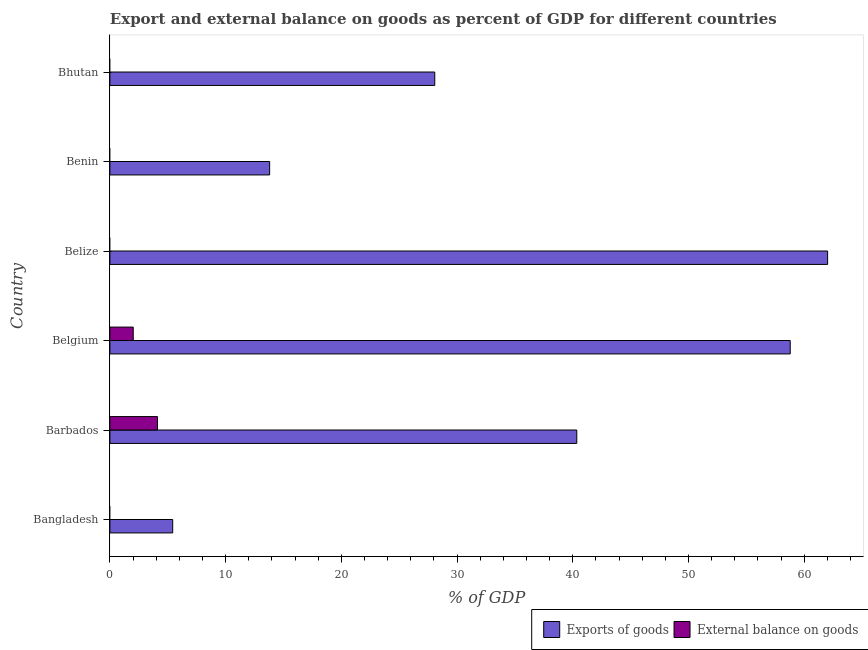Are the number of bars on each tick of the Y-axis equal?
Your response must be concise. No. How many bars are there on the 2nd tick from the bottom?
Ensure brevity in your answer.  2. What is the label of the 2nd group of bars from the top?
Keep it short and to the point. Benin. What is the export of goods as percentage of gdp in Benin?
Offer a very short reply. 13.8. Across all countries, what is the maximum external balance on goods as percentage of gdp?
Your answer should be very brief. 4.11. Across all countries, what is the minimum export of goods as percentage of gdp?
Your answer should be compact. 5.43. In which country was the export of goods as percentage of gdp maximum?
Provide a short and direct response. Belize. What is the total export of goods as percentage of gdp in the graph?
Provide a short and direct response. 208.46. What is the difference between the export of goods as percentage of gdp in Bangladesh and that in Bhutan?
Your answer should be compact. -22.64. What is the difference between the export of goods as percentage of gdp in Barbados and the external balance on goods as percentage of gdp in Belize?
Offer a terse response. 40.35. What is the average external balance on goods as percentage of gdp per country?
Offer a very short reply. 1.02. What is the difference between the external balance on goods as percentage of gdp and export of goods as percentage of gdp in Barbados?
Ensure brevity in your answer.  -36.23. In how many countries, is the external balance on goods as percentage of gdp greater than 18 %?
Provide a succinct answer. 0. What is the ratio of the export of goods as percentage of gdp in Bangladesh to that in Belgium?
Your response must be concise. 0.09. Is the difference between the export of goods as percentage of gdp in Barbados and Belgium greater than the difference between the external balance on goods as percentage of gdp in Barbados and Belgium?
Make the answer very short. No. What is the difference between the highest and the second highest export of goods as percentage of gdp?
Offer a terse response. 3.23. What is the difference between the highest and the lowest export of goods as percentage of gdp?
Offer a very short reply. 56.59. In how many countries, is the export of goods as percentage of gdp greater than the average export of goods as percentage of gdp taken over all countries?
Offer a very short reply. 3. Is the sum of the export of goods as percentage of gdp in Bangladesh and Bhutan greater than the maximum external balance on goods as percentage of gdp across all countries?
Ensure brevity in your answer.  Yes. Are all the bars in the graph horizontal?
Your answer should be very brief. Yes. How many countries are there in the graph?
Provide a succinct answer. 6. What is the difference between two consecutive major ticks on the X-axis?
Your answer should be compact. 10. Are the values on the major ticks of X-axis written in scientific E-notation?
Your answer should be compact. No. Does the graph contain any zero values?
Your answer should be very brief. Yes. Does the graph contain grids?
Your response must be concise. No. What is the title of the graph?
Offer a very short reply. Export and external balance on goods as percent of GDP for different countries. What is the label or title of the X-axis?
Ensure brevity in your answer.  % of GDP. What is the % of GDP of Exports of goods in Bangladesh?
Provide a succinct answer. 5.43. What is the % of GDP of External balance on goods in Bangladesh?
Keep it short and to the point. 0. What is the % of GDP in Exports of goods in Barbados?
Offer a very short reply. 40.35. What is the % of GDP in External balance on goods in Barbados?
Give a very brief answer. 4.11. What is the % of GDP in Exports of goods in Belgium?
Provide a short and direct response. 58.79. What is the % of GDP in External balance on goods in Belgium?
Your answer should be very brief. 2.02. What is the % of GDP of Exports of goods in Belize?
Your response must be concise. 62.02. What is the % of GDP in External balance on goods in Belize?
Give a very brief answer. 0. What is the % of GDP of Exports of goods in Benin?
Your response must be concise. 13.8. What is the % of GDP in Exports of goods in Bhutan?
Ensure brevity in your answer.  28.07. What is the % of GDP of External balance on goods in Bhutan?
Offer a very short reply. 0. Across all countries, what is the maximum % of GDP in Exports of goods?
Make the answer very short. 62.02. Across all countries, what is the maximum % of GDP of External balance on goods?
Provide a short and direct response. 4.11. Across all countries, what is the minimum % of GDP in Exports of goods?
Offer a very short reply. 5.43. Across all countries, what is the minimum % of GDP of External balance on goods?
Give a very brief answer. 0. What is the total % of GDP in Exports of goods in the graph?
Your response must be concise. 208.46. What is the total % of GDP in External balance on goods in the graph?
Your response must be concise. 6.13. What is the difference between the % of GDP in Exports of goods in Bangladesh and that in Barbados?
Give a very brief answer. -34.92. What is the difference between the % of GDP in Exports of goods in Bangladesh and that in Belgium?
Ensure brevity in your answer.  -53.36. What is the difference between the % of GDP of Exports of goods in Bangladesh and that in Belize?
Give a very brief answer. -56.59. What is the difference between the % of GDP of Exports of goods in Bangladesh and that in Benin?
Give a very brief answer. -8.38. What is the difference between the % of GDP in Exports of goods in Bangladesh and that in Bhutan?
Your response must be concise. -22.64. What is the difference between the % of GDP in Exports of goods in Barbados and that in Belgium?
Offer a very short reply. -18.44. What is the difference between the % of GDP in External balance on goods in Barbados and that in Belgium?
Offer a very short reply. 2.1. What is the difference between the % of GDP of Exports of goods in Barbados and that in Belize?
Your response must be concise. -21.67. What is the difference between the % of GDP in Exports of goods in Barbados and that in Benin?
Keep it short and to the point. 26.54. What is the difference between the % of GDP of Exports of goods in Barbados and that in Bhutan?
Keep it short and to the point. 12.27. What is the difference between the % of GDP in Exports of goods in Belgium and that in Belize?
Keep it short and to the point. -3.23. What is the difference between the % of GDP of Exports of goods in Belgium and that in Benin?
Keep it short and to the point. 44.98. What is the difference between the % of GDP of Exports of goods in Belgium and that in Bhutan?
Offer a very short reply. 30.72. What is the difference between the % of GDP of Exports of goods in Belize and that in Benin?
Keep it short and to the point. 48.22. What is the difference between the % of GDP of Exports of goods in Belize and that in Bhutan?
Your answer should be compact. 33.95. What is the difference between the % of GDP in Exports of goods in Benin and that in Bhutan?
Your answer should be very brief. -14.27. What is the difference between the % of GDP of Exports of goods in Bangladesh and the % of GDP of External balance on goods in Barbados?
Offer a very short reply. 1.31. What is the difference between the % of GDP of Exports of goods in Bangladesh and the % of GDP of External balance on goods in Belgium?
Keep it short and to the point. 3.41. What is the difference between the % of GDP in Exports of goods in Barbados and the % of GDP in External balance on goods in Belgium?
Your answer should be very brief. 38.33. What is the average % of GDP of Exports of goods per country?
Your answer should be compact. 34.74. What is the average % of GDP of External balance on goods per country?
Keep it short and to the point. 1.02. What is the difference between the % of GDP in Exports of goods and % of GDP in External balance on goods in Barbados?
Your answer should be compact. 36.23. What is the difference between the % of GDP in Exports of goods and % of GDP in External balance on goods in Belgium?
Your response must be concise. 56.77. What is the ratio of the % of GDP in Exports of goods in Bangladesh to that in Barbados?
Offer a very short reply. 0.13. What is the ratio of the % of GDP of Exports of goods in Bangladesh to that in Belgium?
Give a very brief answer. 0.09. What is the ratio of the % of GDP of Exports of goods in Bangladesh to that in Belize?
Your response must be concise. 0.09. What is the ratio of the % of GDP of Exports of goods in Bangladesh to that in Benin?
Provide a succinct answer. 0.39. What is the ratio of the % of GDP in Exports of goods in Bangladesh to that in Bhutan?
Your response must be concise. 0.19. What is the ratio of the % of GDP of Exports of goods in Barbados to that in Belgium?
Your response must be concise. 0.69. What is the ratio of the % of GDP of External balance on goods in Barbados to that in Belgium?
Give a very brief answer. 2.04. What is the ratio of the % of GDP in Exports of goods in Barbados to that in Belize?
Make the answer very short. 0.65. What is the ratio of the % of GDP in Exports of goods in Barbados to that in Benin?
Keep it short and to the point. 2.92. What is the ratio of the % of GDP of Exports of goods in Barbados to that in Bhutan?
Offer a very short reply. 1.44. What is the ratio of the % of GDP of Exports of goods in Belgium to that in Belize?
Provide a succinct answer. 0.95. What is the ratio of the % of GDP in Exports of goods in Belgium to that in Benin?
Keep it short and to the point. 4.26. What is the ratio of the % of GDP in Exports of goods in Belgium to that in Bhutan?
Give a very brief answer. 2.09. What is the ratio of the % of GDP in Exports of goods in Belize to that in Benin?
Your answer should be very brief. 4.49. What is the ratio of the % of GDP in Exports of goods in Belize to that in Bhutan?
Make the answer very short. 2.21. What is the ratio of the % of GDP in Exports of goods in Benin to that in Bhutan?
Provide a short and direct response. 0.49. What is the difference between the highest and the second highest % of GDP in Exports of goods?
Your answer should be very brief. 3.23. What is the difference between the highest and the lowest % of GDP in Exports of goods?
Provide a short and direct response. 56.59. What is the difference between the highest and the lowest % of GDP of External balance on goods?
Offer a terse response. 4.11. 